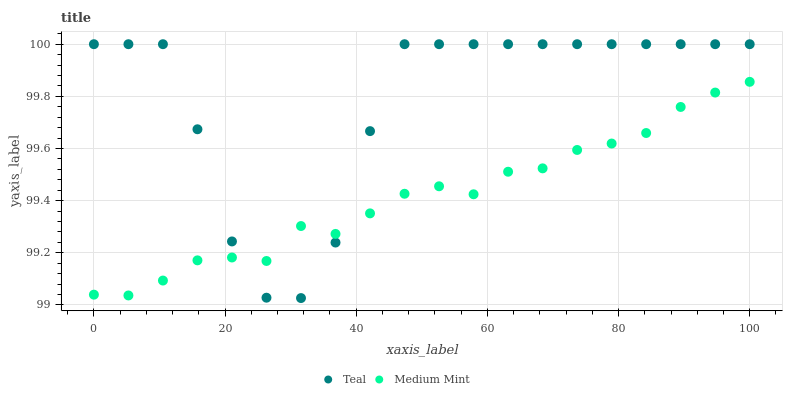Does Medium Mint have the minimum area under the curve?
Answer yes or no. Yes. Does Teal have the maximum area under the curve?
Answer yes or no. Yes. Does Teal have the minimum area under the curve?
Answer yes or no. No. Is Medium Mint the smoothest?
Answer yes or no. Yes. Is Teal the roughest?
Answer yes or no. Yes. Is Teal the smoothest?
Answer yes or no. No. Does Teal have the lowest value?
Answer yes or no. Yes. Does Teal have the highest value?
Answer yes or no. Yes. Does Teal intersect Medium Mint?
Answer yes or no. Yes. Is Teal less than Medium Mint?
Answer yes or no. No. Is Teal greater than Medium Mint?
Answer yes or no. No. 